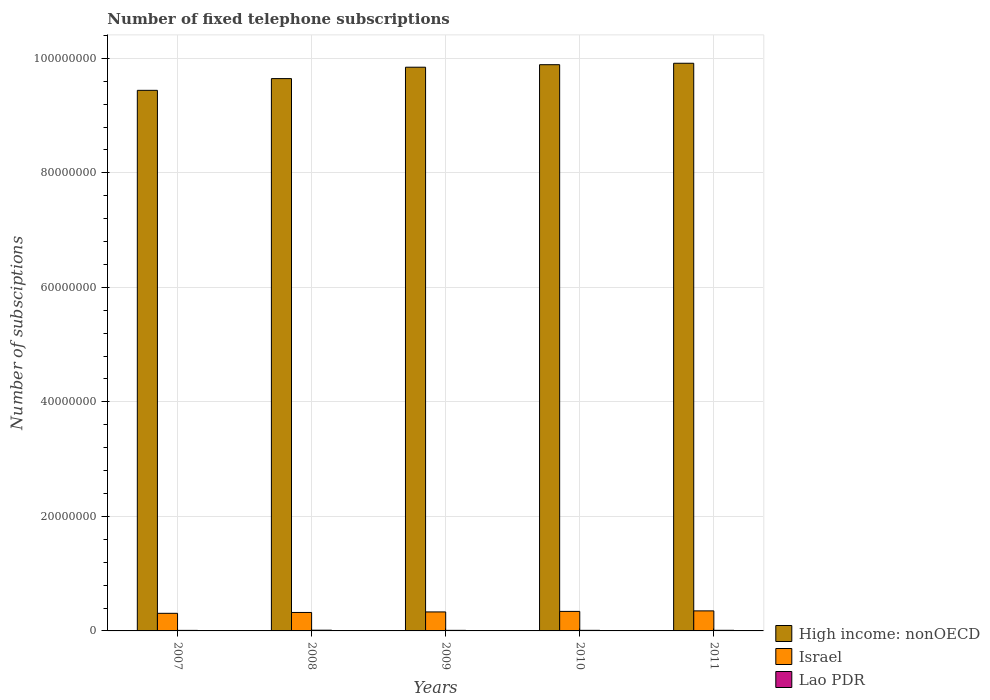How many different coloured bars are there?
Offer a very short reply. 3. Are the number of bars per tick equal to the number of legend labels?
Your answer should be very brief. Yes. Are the number of bars on each tick of the X-axis equal?
Ensure brevity in your answer.  Yes. How many bars are there on the 4th tick from the right?
Your answer should be very brief. 3. What is the number of fixed telephone subscriptions in Lao PDR in 2010?
Give a very brief answer. 1.03e+05. Across all years, what is the maximum number of fixed telephone subscriptions in Lao PDR?
Ensure brevity in your answer.  1.28e+05. Across all years, what is the minimum number of fixed telephone subscriptions in High income: nonOECD?
Your answer should be compact. 9.44e+07. In which year was the number of fixed telephone subscriptions in High income: nonOECD maximum?
Offer a terse response. 2011. What is the total number of fixed telephone subscriptions in High income: nonOECD in the graph?
Offer a terse response. 4.87e+08. What is the difference between the number of fixed telephone subscriptions in High income: nonOECD in 2009 and that in 2010?
Give a very brief answer. -4.41e+05. What is the difference between the number of fixed telephone subscriptions in Israel in 2011 and the number of fixed telephone subscriptions in High income: nonOECD in 2010?
Your answer should be compact. -9.54e+07. What is the average number of fixed telephone subscriptions in High income: nonOECD per year?
Offer a very short reply. 9.75e+07. In the year 2010, what is the difference between the number of fixed telephone subscriptions in High income: nonOECD and number of fixed telephone subscriptions in Israel?
Offer a terse response. 9.55e+07. In how many years, is the number of fixed telephone subscriptions in Israel greater than 24000000?
Your answer should be very brief. 0. What is the ratio of the number of fixed telephone subscriptions in Lao PDR in 2008 to that in 2009?
Your response must be concise. 1.28. What is the difference between the highest and the second highest number of fixed telephone subscriptions in Israel?
Provide a short and direct response. 9.20e+04. What is the difference between the highest and the lowest number of fixed telephone subscriptions in Israel?
Offer a very short reply. 4.25e+05. What does the 2nd bar from the left in 2009 represents?
Give a very brief answer. Israel. What does the 1st bar from the right in 2010 represents?
Ensure brevity in your answer.  Lao PDR. Is it the case that in every year, the sum of the number of fixed telephone subscriptions in Israel and number of fixed telephone subscriptions in High income: nonOECD is greater than the number of fixed telephone subscriptions in Lao PDR?
Give a very brief answer. Yes. What is the difference between two consecutive major ticks on the Y-axis?
Offer a terse response. 2.00e+07. Does the graph contain grids?
Keep it short and to the point. Yes. How many legend labels are there?
Offer a terse response. 3. How are the legend labels stacked?
Make the answer very short. Vertical. What is the title of the graph?
Provide a short and direct response. Number of fixed telephone subscriptions. Does "Romania" appear as one of the legend labels in the graph?
Offer a terse response. No. What is the label or title of the X-axis?
Keep it short and to the point. Years. What is the label or title of the Y-axis?
Your answer should be compact. Number of subsciptions. What is the Number of subsciptions in High income: nonOECD in 2007?
Make the answer very short. 9.44e+07. What is the Number of subsciptions of Israel in 2007?
Make the answer very short. 3.07e+06. What is the Number of subsciptions in Lao PDR in 2007?
Make the answer very short. 9.48e+04. What is the Number of subsciptions in High income: nonOECD in 2008?
Your answer should be compact. 9.65e+07. What is the Number of subsciptions in Israel in 2008?
Give a very brief answer. 3.22e+06. What is the Number of subsciptions in Lao PDR in 2008?
Offer a terse response. 1.28e+05. What is the Number of subsciptions of High income: nonOECD in 2009?
Give a very brief answer. 9.84e+07. What is the Number of subsciptions of Israel in 2009?
Give a very brief answer. 3.32e+06. What is the Number of subsciptions of Lao PDR in 2009?
Keep it short and to the point. 1.00e+05. What is the Number of subsciptions in High income: nonOECD in 2010?
Provide a short and direct response. 9.89e+07. What is the Number of subsciptions of Israel in 2010?
Your response must be concise. 3.41e+06. What is the Number of subsciptions of Lao PDR in 2010?
Provide a short and direct response. 1.03e+05. What is the Number of subsciptions of High income: nonOECD in 2011?
Your answer should be very brief. 9.91e+07. What is the Number of subsciptions in Israel in 2011?
Your answer should be compact. 3.50e+06. What is the Number of subsciptions of Lao PDR in 2011?
Give a very brief answer. 1.08e+05. Across all years, what is the maximum Number of subsciptions in High income: nonOECD?
Ensure brevity in your answer.  9.91e+07. Across all years, what is the maximum Number of subsciptions in Israel?
Make the answer very short. 3.50e+06. Across all years, what is the maximum Number of subsciptions in Lao PDR?
Your answer should be very brief. 1.28e+05. Across all years, what is the minimum Number of subsciptions in High income: nonOECD?
Provide a succinct answer. 9.44e+07. Across all years, what is the minimum Number of subsciptions of Israel?
Provide a short and direct response. 3.07e+06. Across all years, what is the minimum Number of subsciptions in Lao PDR?
Your answer should be compact. 9.48e+04. What is the total Number of subsciptions of High income: nonOECD in the graph?
Provide a succinct answer. 4.87e+08. What is the total Number of subsciptions of Israel in the graph?
Offer a terse response. 1.65e+07. What is the total Number of subsciptions in Lao PDR in the graph?
Your answer should be compact. 5.34e+05. What is the difference between the Number of subsciptions in High income: nonOECD in 2007 and that in 2008?
Keep it short and to the point. -2.05e+06. What is the difference between the Number of subsciptions in Israel in 2007 and that in 2008?
Offer a terse response. -1.49e+05. What is the difference between the Number of subsciptions of Lao PDR in 2007 and that in 2008?
Make the answer very short. -3.30e+04. What is the difference between the Number of subsciptions of High income: nonOECD in 2007 and that in 2009?
Offer a very short reply. -4.04e+06. What is the difference between the Number of subsciptions of Israel in 2007 and that in 2009?
Offer a very short reply. -2.41e+05. What is the difference between the Number of subsciptions in Lao PDR in 2007 and that in 2009?
Provide a short and direct response. -5400. What is the difference between the Number of subsciptions of High income: nonOECD in 2007 and that in 2010?
Your answer should be very brief. -4.48e+06. What is the difference between the Number of subsciptions of Israel in 2007 and that in 2010?
Provide a succinct answer. -3.33e+05. What is the difference between the Number of subsciptions in Lao PDR in 2007 and that in 2010?
Your answer should be very brief. -8274. What is the difference between the Number of subsciptions of High income: nonOECD in 2007 and that in 2011?
Provide a succinct answer. -4.73e+06. What is the difference between the Number of subsciptions of Israel in 2007 and that in 2011?
Offer a very short reply. -4.25e+05. What is the difference between the Number of subsciptions in Lao PDR in 2007 and that in 2011?
Your answer should be compact. -1.28e+04. What is the difference between the Number of subsciptions of High income: nonOECD in 2008 and that in 2009?
Your answer should be very brief. -1.99e+06. What is the difference between the Number of subsciptions of Israel in 2008 and that in 2009?
Give a very brief answer. -9.20e+04. What is the difference between the Number of subsciptions in Lao PDR in 2008 and that in 2009?
Your answer should be compact. 2.76e+04. What is the difference between the Number of subsciptions in High income: nonOECD in 2008 and that in 2010?
Give a very brief answer. -2.43e+06. What is the difference between the Number of subsciptions in Israel in 2008 and that in 2010?
Offer a terse response. -1.84e+05. What is the difference between the Number of subsciptions of Lao PDR in 2008 and that in 2010?
Give a very brief answer. 2.47e+04. What is the difference between the Number of subsciptions of High income: nonOECD in 2008 and that in 2011?
Your answer should be compact. -2.68e+06. What is the difference between the Number of subsciptions of Israel in 2008 and that in 2011?
Ensure brevity in your answer.  -2.76e+05. What is the difference between the Number of subsciptions in Lao PDR in 2008 and that in 2011?
Provide a short and direct response. 2.02e+04. What is the difference between the Number of subsciptions in High income: nonOECD in 2009 and that in 2010?
Provide a succinct answer. -4.41e+05. What is the difference between the Number of subsciptions of Israel in 2009 and that in 2010?
Keep it short and to the point. -9.20e+04. What is the difference between the Number of subsciptions of Lao PDR in 2009 and that in 2010?
Offer a very short reply. -2874. What is the difference between the Number of subsciptions in High income: nonOECD in 2009 and that in 2011?
Provide a succinct answer. -6.91e+05. What is the difference between the Number of subsciptions in Israel in 2009 and that in 2011?
Your answer should be very brief. -1.84e+05. What is the difference between the Number of subsciptions in Lao PDR in 2009 and that in 2011?
Ensure brevity in your answer.  -7415. What is the difference between the Number of subsciptions in High income: nonOECD in 2010 and that in 2011?
Your answer should be very brief. -2.50e+05. What is the difference between the Number of subsciptions in Israel in 2010 and that in 2011?
Offer a very short reply. -9.20e+04. What is the difference between the Number of subsciptions of Lao PDR in 2010 and that in 2011?
Offer a very short reply. -4541. What is the difference between the Number of subsciptions of High income: nonOECD in 2007 and the Number of subsciptions of Israel in 2008?
Provide a short and direct response. 9.12e+07. What is the difference between the Number of subsciptions of High income: nonOECD in 2007 and the Number of subsciptions of Lao PDR in 2008?
Offer a terse response. 9.43e+07. What is the difference between the Number of subsciptions of Israel in 2007 and the Number of subsciptions of Lao PDR in 2008?
Your answer should be compact. 2.95e+06. What is the difference between the Number of subsciptions of High income: nonOECD in 2007 and the Number of subsciptions of Israel in 2009?
Give a very brief answer. 9.11e+07. What is the difference between the Number of subsciptions in High income: nonOECD in 2007 and the Number of subsciptions in Lao PDR in 2009?
Provide a short and direct response. 9.43e+07. What is the difference between the Number of subsciptions of Israel in 2007 and the Number of subsciptions of Lao PDR in 2009?
Offer a very short reply. 2.97e+06. What is the difference between the Number of subsciptions of High income: nonOECD in 2007 and the Number of subsciptions of Israel in 2010?
Provide a succinct answer. 9.10e+07. What is the difference between the Number of subsciptions in High income: nonOECD in 2007 and the Number of subsciptions in Lao PDR in 2010?
Keep it short and to the point. 9.43e+07. What is the difference between the Number of subsciptions of Israel in 2007 and the Number of subsciptions of Lao PDR in 2010?
Offer a very short reply. 2.97e+06. What is the difference between the Number of subsciptions of High income: nonOECD in 2007 and the Number of subsciptions of Israel in 2011?
Offer a terse response. 9.09e+07. What is the difference between the Number of subsciptions of High income: nonOECD in 2007 and the Number of subsciptions of Lao PDR in 2011?
Your response must be concise. 9.43e+07. What is the difference between the Number of subsciptions in Israel in 2007 and the Number of subsciptions in Lao PDR in 2011?
Provide a short and direct response. 2.97e+06. What is the difference between the Number of subsciptions of High income: nonOECD in 2008 and the Number of subsciptions of Israel in 2009?
Your answer should be very brief. 9.31e+07. What is the difference between the Number of subsciptions of High income: nonOECD in 2008 and the Number of subsciptions of Lao PDR in 2009?
Ensure brevity in your answer.  9.64e+07. What is the difference between the Number of subsciptions in Israel in 2008 and the Number of subsciptions in Lao PDR in 2009?
Your response must be concise. 3.12e+06. What is the difference between the Number of subsciptions in High income: nonOECD in 2008 and the Number of subsciptions in Israel in 2010?
Keep it short and to the point. 9.30e+07. What is the difference between the Number of subsciptions in High income: nonOECD in 2008 and the Number of subsciptions in Lao PDR in 2010?
Give a very brief answer. 9.63e+07. What is the difference between the Number of subsciptions in Israel in 2008 and the Number of subsciptions in Lao PDR in 2010?
Make the answer very short. 3.12e+06. What is the difference between the Number of subsciptions in High income: nonOECD in 2008 and the Number of subsciptions in Israel in 2011?
Provide a short and direct response. 9.30e+07. What is the difference between the Number of subsciptions of High income: nonOECD in 2008 and the Number of subsciptions of Lao PDR in 2011?
Offer a very short reply. 9.63e+07. What is the difference between the Number of subsciptions in Israel in 2008 and the Number of subsciptions in Lao PDR in 2011?
Provide a short and direct response. 3.12e+06. What is the difference between the Number of subsciptions of High income: nonOECD in 2009 and the Number of subsciptions of Israel in 2010?
Your answer should be compact. 9.50e+07. What is the difference between the Number of subsciptions of High income: nonOECD in 2009 and the Number of subsciptions of Lao PDR in 2010?
Your answer should be very brief. 9.83e+07. What is the difference between the Number of subsciptions in Israel in 2009 and the Number of subsciptions in Lao PDR in 2010?
Provide a succinct answer. 3.21e+06. What is the difference between the Number of subsciptions in High income: nonOECD in 2009 and the Number of subsciptions in Israel in 2011?
Make the answer very short. 9.49e+07. What is the difference between the Number of subsciptions in High income: nonOECD in 2009 and the Number of subsciptions in Lao PDR in 2011?
Give a very brief answer. 9.83e+07. What is the difference between the Number of subsciptions of Israel in 2009 and the Number of subsciptions of Lao PDR in 2011?
Keep it short and to the point. 3.21e+06. What is the difference between the Number of subsciptions in High income: nonOECD in 2010 and the Number of subsciptions in Israel in 2011?
Keep it short and to the point. 9.54e+07. What is the difference between the Number of subsciptions in High income: nonOECD in 2010 and the Number of subsciptions in Lao PDR in 2011?
Ensure brevity in your answer.  9.88e+07. What is the difference between the Number of subsciptions in Israel in 2010 and the Number of subsciptions in Lao PDR in 2011?
Ensure brevity in your answer.  3.30e+06. What is the average Number of subsciptions of High income: nonOECD per year?
Keep it short and to the point. 9.75e+07. What is the average Number of subsciptions in Israel per year?
Your response must be concise. 3.30e+06. What is the average Number of subsciptions of Lao PDR per year?
Keep it short and to the point. 1.07e+05. In the year 2007, what is the difference between the Number of subsciptions of High income: nonOECD and Number of subsciptions of Israel?
Keep it short and to the point. 9.13e+07. In the year 2007, what is the difference between the Number of subsciptions in High income: nonOECD and Number of subsciptions in Lao PDR?
Ensure brevity in your answer.  9.43e+07. In the year 2007, what is the difference between the Number of subsciptions of Israel and Number of subsciptions of Lao PDR?
Offer a very short reply. 2.98e+06. In the year 2008, what is the difference between the Number of subsciptions in High income: nonOECD and Number of subsciptions in Israel?
Provide a succinct answer. 9.32e+07. In the year 2008, what is the difference between the Number of subsciptions in High income: nonOECD and Number of subsciptions in Lao PDR?
Your answer should be very brief. 9.63e+07. In the year 2008, what is the difference between the Number of subsciptions in Israel and Number of subsciptions in Lao PDR?
Your response must be concise. 3.10e+06. In the year 2009, what is the difference between the Number of subsciptions of High income: nonOECD and Number of subsciptions of Israel?
Keep it short and to the point. 9.51e+07. In the year 2009, what is the difference between the Number of subsciptions of High income: nonOECD and Number of subsciptions of Lao PDR?
Provide a succinct answer. 9.83e+07. In the year 2009, what is the difference between the Number of subsciptions in Israel and Number of subsciptions in Lao PDR?
Keep it short and to the point. 3.22e+06. In the year 2010, what is the difference between the Number of subsciptions of High income: nonOECD and Number of subsciptions of Israel?
Your response must be concise. 9.55e+07. In the year 2010, what is the difference between the Number of subsciptions of High income: nonOECD and Number of subsciptions of Lao PDR?
Ensure brevity in your answer.  9.88e+07. In the year 2010, what is the difference between the Number of subsciptions in Israel and Number of subsciptions in Lao PDR?
Your response must be concise. 3.30e+06. In the year 2011, what is the difference between the Number of subsciptions of High income: nonOECD and Number of subsciptions of Israel?
Your response must be concise. 9.56e+07. In the year 2011, what is the difference between the Number of subsciptions in High income: nonOECD and Number of subsciptions in Lao PDR?
Provide a succinct answer. 9.90e+07. In the year 2011, what is the difference between the Number of subsciptions in Israel and Number of subsciptions in Lao PDR?
Offer a very short reply. 3.39e+06. What is the ratio of the Number of subsciptions in High income: nonOECD in 2007 to that in 2008?
Provide a succinct answer. 0.98. What is the ratio of the Number of subsciptions in Israel in 2007 to that in 2008?
Keep it short and to the point. 0.95. What is the ratio of the Number of subsciptions of Lao PDR in 2007 to that in 2008?
Offer a terse response. 0.74. What is the ratio of the Number of subsciptions of Israel in 2007 to that in 2009?
Provide a succinct answer. 0.93. What is the ratio of the Number of subsciptions of Lao PDR in 2007 to that in 2009?
Make the answer very short. 0.95. What is the ratio of the Number of subsciptions of High income: nonOECD in 2007 to that in 2010?
Offer a very short reply. 0.95. What is the ratio of the Number of subsciptions in Israel in 2007 to that in 2010?
Ensure brevity in your answer.  0.9. What is the ratio of the Number of subsciptions in Lao PDR in 2007 to that in 2010?
Ensure brevity in your answer.  0.92. What is the ratio of the Number of subsciptions of High income: nonOECD in 2007 to that in 2011?
Offer a very short reply. 0.95. What is the ratio of the Number of subsciptions in Israel in 2007 to that in 2011?
Ensure brevity in your answer.  0.88. What is the ratio of the Number of subsciptions in Lao PDR in 2007 to that in 2011?
Your response must be concise. 0.88. What is the ratio of the Number of subsciptions of High income: nonOECD in 2008 to that in 2009?
Provide a short and direct response. 0.98. What is the ratio of the Number of subsciptions of Israel in 2008 to that in 2009?
Your answer should be compact. 0.97. What is the ratio of the Number of subsciptions in Lao PDR in 2008 to that in 2009?
Give a very brief answer. 1.28. What is the ratio of the Number of subsciptions in High income: nonOECD in 2008 to that in 2010?
Keep it short and to the point. 0.98. What is the ratio of the Number of subsciptions in Israel in 2008 to that in 2010?
Make the answer very short. 0.95. What is the ratio of the Number of subsciptions of Lao PDR in 2008 to that in 2010?
Offer a terse response. 1.24. What is the ratio of the Number of subsciptions in High income: nonOECD in 2008 to that in 2011?
Offer a terse response. 0.97. What is the ratio of the Number of subsciptions in Israel in 2008 to that in 2011?
Your response must be concise. 0.92. What is the ratio of the Number of subsciptions of Lao PDR in 2008 to that in 2011?
Offer a very short reply. 1.19. What is the ratio of the Number of subsciptions of Lao PDR in 2009 to that in 2010?
Give a very brief answer. 0.97. What is the ratio of the Number of subsciptions in High income: nonOECD in 2009 to that in 2011?
Provide a short and direct response. 0.99. What is the ratio of the Number of subsciptions of Israel in 2009 to that in 2011?
Offer a terse response. 0.95. What is the ratio of the Number of subsciptions in Lao PDR in 2009 to that in 2011?
Offer a very short reply. 0.93. What is the ratio of the Number of subsciptions in High income: nonOECD in 2010 to that in 2011?
Provide a short and direct response. 1. What is the ratio of the Number of subsciptions of Israel in 2010 to that in 2011?
Offer a terse response. 0.97. What is the ratio of the Number of subsciptions in Lao PDR in 2010 to that in 2011?
Offer a very short reply. 0.96. What is the difference between the highest and the second highest Number of subsciptions in High income: nonOECD?
Keep it short and to the point. 2.50e+05. What is the difference between the highest and the second highest Number of subsciptions of Israel?
Ensure brevity in your answer.  9.20e+04. What is the difference between the highest and the second highest Number of subsciptions in Lao PDR?
Ensure brevity in your answer.  2.02e+04. What is the difference between the highest and the lowest Number of subsciptions of High income: nonOECD?
Make the answer very short. 4.73e+06. What is the difference between the highest and the lowest Number of subsciptions in Israel?
Your response must be concise. 4.25e+05. What is the difference between the highest and the lowest Number of subsciptions of Lao PDR?
Your response must be concise. 3.30e+04. 